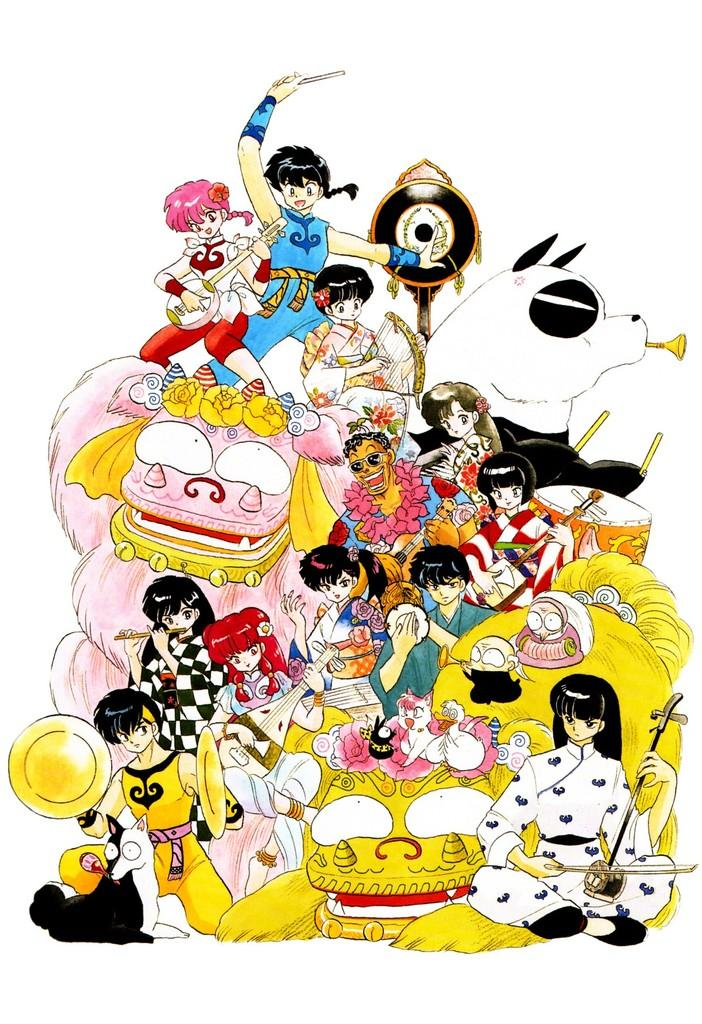What type of image is present in the picture? There is a picture of cartoons in the image. What type of juice is being served in the image? There is no juice present in the image; it only contains a picture of cartoons. 